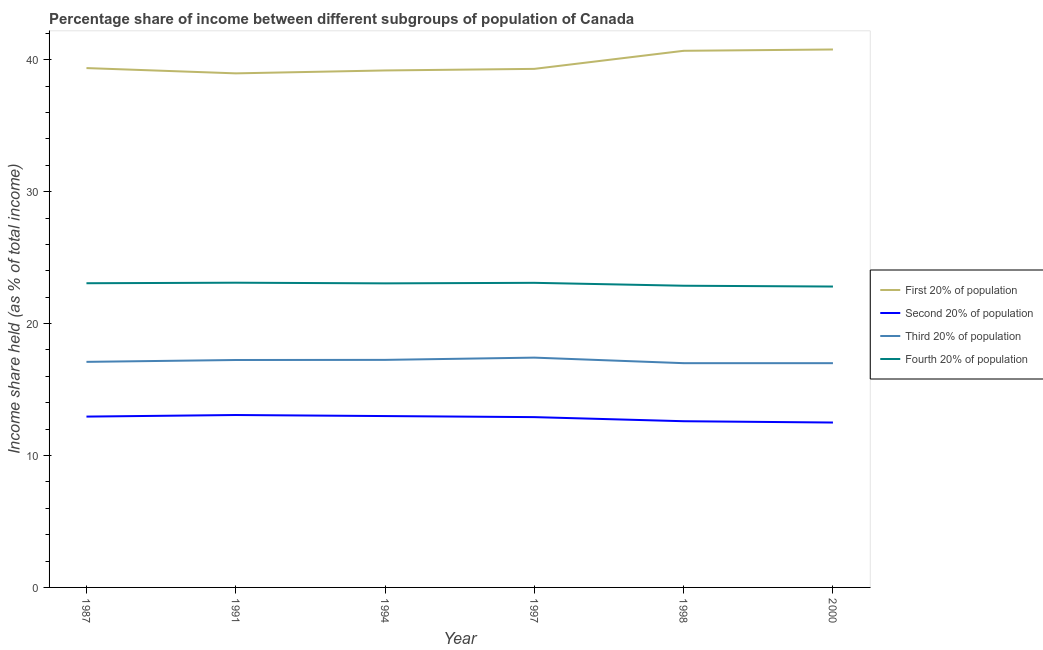Is the number of lines equal to the number of legend labels?
Ensure brevity in your answer.  Yes. What is the share of the income held by second 20% of the population in 1994?
Offer a terse response. 12.99. Across all years, what is the maximum share of the income held by second 20% of the population?
Ensure brevity in your answer.  13.07. Across all years, what is the minimum share of the income held by first 20% of the population?
Your answer should be very brief. 38.97. What is the total share of the income held by first 20% of the population in the graph?
Ensure brevity in your answer.  238.3. What is the difference between the share of the income held by first 20% of the population in 1997 and that in 1998?
Make the answer very short. -1.37. What is the difference between the share of the income held by third 20% of the population in 1994 and the share of the income held by first 20% of the population in 1987?
Your response must be concise. -22.12. What is the average share of the income held by fourth 20% of the population per year?
Offer a terse response. 23. In the year 1997, what is the difference between the share of the income held by second 20% of the population and share of the income held by third 20% of the population?
Offer a very short reply. -4.51. In how many years, is the share of the income held by second 20% of the population greater than 20 %?
Your answer should be very brief. 0. What is the ratio of the share of the income held by fourth 20% of the population in 1987 to that in 1997?
Keep it short and to the point. 1. Is the difference between the share of the income held by first 20% of the population in 1994 and 1998 greater than the difference between the share of the income held by second 20% of the population in 1994 and 1998?
Give a very brief answer. No. What is the difference between the highest and the second highest share of the income held by first 20% of the population?
Make the answer very short. 0.1. What is the difference between the highest and the lowest share of the income held by third 20% of the population?
Your answer should be very brief. 0.42. In how many years, is the share of the income held by third 20% of the population greater than the average share of the income held by third 20% of the population taken over all years?
Provide a short and direct response. 3. Is it the case that in every year, the sum of the share of the income held by first 20% of the population and share of the income held by second 20% of the population is greater than the share of the income held by third 20% of the population?
Make the answer very short. Yes. How many lines are there?
Your answer should be compact. 4. Are the values on the major ticks of Y-axis written in scientific E-notation?
Make the answer very short. No. Does the graph contain any zero values?
Ensure brevity in your answer.  No. How many legend labels are there?
Ensure brevity in your answer.  4. How are the legend labels stacked?
Offer a very short reply. Vertical. What is the title of the graph?
Offer a terse response. Percentage share of income between different subgroups of population of Canada. Does "Offering training" appear as one of the legend labels in the graph?
Your answer should be compact. No. What is the label or title of the X-axis?
Your response must be concise. Year. What is the label or title of the Y-axis?
Your answer should be very brief. Income share held (as % of total income). What is the Income share held (as % of total income) in First 20% of population in 1987?
Offer a terse response. 39.37. What is the Income share held (as % of total income) in Second 20% of population in 1987?
Keep it short and to the point. 12.95. What is the Income share held (as % of total income) in Fourth 20% of population in 1987?
Offer a terse response. 23.06. What is the Income share held (as % of total income) in First 20% of population in 1991?
Ensure brevity in your answer.  38.97. What is the Income share held (as % of total income) in Second 20% of population in 1991?
Make the answer very short. 13.07. What is the Income share held (as % of total income) of Third 20% of population in 1991?
Your answer should be compact. 17.24. What is the Income share held (as % of total income) in Fourth 20% of population in 1991?
Your response must be concise. 23.1. What is the Income share held (as % of total income) of First 20% of population in 1994?
Ensure brevity in your answer.  39.19. What is the Income share held (as % of total income) in Second 20% of population in 1994?
Keep it short and to the point. 12.99. What is the Income share held (as % of total income) of Third 20% of population in 1994?
Provide a short and direct response. 17.25. What is the Income share held (as % of total income) in Fourth 20% of population in 1994?
Keep it short and to the point. 23.05. What is the Income share held (as % of total income) of First 20% of population in 1997?
Provide a short and direct response. 39.31. What is the Income share held (as % of total income) of Second 20% of population in 1997?
Ensure brevity in your answer.  12.91. What is the Income share held (as % of total income) of Third 20% of population in 1997?
Offer a terse response. 17.42. What is the Income share held (as % of total income) in Fourth 20% of population in 1997?
Provide a short and direct response. 23.09. What is the Income share held (as % of total income) in First 20% of population in 1998?
Provide a succinct answer. 40.68. What is the Income share held (as % of total income) of Third 20% of population in 1998?
Give a very brief answer. 17. What is the Income share held (as % of total income) of Fourth 20% of population in 1998?
Offer a very short reply. 22.87. What is the Income share held (as % of total income) of First 20% of population in 2000?
Keep it short and to the point. 40.78. What is the Income share held (as % of total income) in Third 20% of population in 2000?
Your answer should be compact. 17. What is the Income share held (as % of total income) of Fourth 20% of population in 2000?
Ensure brevity in your answer.  22.81. Across all years, what is the maximum Income share held (as % of total income) of First 20% of population?
Give a very brief answer. 40.78. Across all years, what is the maximum Income share held (as % of total income) of Second 20% of population?
Keep it short and to the point. 13.07. Across all years, what is the maximum Income share held (as % of total income) of Third 20% of population?
Offer a terse response. 17.42. Across all years, what is the maximum Income share held (as % of total income) in Fourth 20% of population?
Make the answer very short. 23.1. Across all years, what is the minimum Income share held (as % of total income) in First 20% of population?
Provide a succinct answer. 38.97. Across all years, what is the minimum Income share held (as % of total income) in Third 20% of population?
Your response must be concise. 17. Across all years, what is the minimum Income share held (as % of total income) of Fourth 20% of population?
Your response must be concise. 22.81. What is the total Income share held (as % of total income) in First 20% of population in the graph?
Ensure brevity in your answer.  238.3. What is the total Income share held (as % of total income) in Second 20% of population in the graph?
Ensure brevity in your answer.  77.02. What is the total Income share held (as % of total income) of Third 20% of population in the graph?
Your answer should be compact. 103.01. What is the total Income share held (as % of total income) of Fourth 20% of population in the graph?
Provide a succinct answer. 137.98. What is the difference between the Income share held (as % of total income) in First 20% of population in 1987 and that in 1991?
Provide a short and direct response. 0.4. What is the difference between the Income share held (as % of total income) in Second 20% of population in 1987 and that in 1991?
Your response must be concise. -0.12. What is the difference between the Income share held (as % of total income) of Third 20% of population in 1987 and that in 1991?
Offer a terse response. -0.14. What is the difference between the Income share held (as % of total income) in Fourth 20% of population in 1987 and that in 1991?
Offer a terse response. -0.04. What is the difference between the Income share held (as % of total income) of First 20% of population in 1987 and that in 1994?
Keep it short and to the point. 0.18. What is the difference between the Income share held (as % of total income) in Second 20% of population in 1987 and that in 1994?
Keep it short and to the point. -0.04. What is the difference between the Income share held (as % of total income) in First 20% of population in 1987 and that in 1997?
Keep it short and to the point. 0.06. What is the difference between the Income share held (as % of total income) in Third 20% of population in 1987 and that in 1997?
Offer a very short reply. -0.32. What is the difference between the Income share held (as % of total income) in Fourth 20% of population in 1987 and that in 1997?
Provide a short and direct response. -0.03. What is the difference between the Income share held (as % of total income) in First 20% of population in 1987 and that in 1998?
Make the answer very short. -1.31. What is the difference between the Income share held (as % of total income) in Fourth 20% of population in 1987 and that in 1998?
Give a very brief answer. 0.19. What is the difference between the Income share held (as % of total income) of First 20% of population in 1987 and that in 2000?
Your answer should be compact. -1.41. What is the difference between the Income share held (as % of total income) in Second 20% of population in 1987 and that in 2000?
Keep it short and to the point. 0.45. What is the difference between the Income share held (as % of total income) of Third 20% of population in 1987 and that in 2000?
Provide a short and direct response. 0.1. What is the difference between the Income share held (as % of total income) of First 20% of population in 1991 and that in 1994?
Give a very brief answer. -0.22. What is the difference between the Income share held (as % of total income) in Second 20% of population in 1991 and that in 1994?
Keep it short and to the point. 0.08. What is the difference between the Income share held (as % of total income) in Third 20% of population in 1991 and that in 1994?
Your response must be concise. -0.01. What is the difference between the Income share held (as % of total income) in First 20% of population in 1991 and that in 1997?
Offer a very short reply. -0.34. What is the difference between the Income share held (as % of total income) in Second 20% of population in 1991 and that in 1997?
Your answer should be compact. 0.16. What is the difference between the Income share held (as % of total income) in Third 20% of population in 1991 and that in 1997?
Ensure brevity in your answer.  -0.18. What is the difference between the Income share held (as % of total income) of First 20% of population in 1991 and that in 1998?
Keep it short and to the point. -1.71. What is the difference between the Income share held (as % of total income) in Second 20% of population in 1991 and that in 1998?
Give a very brief answer. 0.47. What is the difference between the Income share held (as % of total income) of Third 20% of population in 1991 and that in 1998?
Your response must be concise. 0.24. What is the difference between the Income share held (as % of total income) in Fourth 20% of population in 1991 and that in 1998?
Offer a very short reply. 0.23. What is the difference between the Income share held (as % of total income) of First 20% of population in 1991 and that in 2000?
Your answer should be very brief. -1.81. What is the difference between the Income share held (as % of total income) of Second 20% of population in 1991 and that in 2000?
Make the answer very short. 0.57. What is the difference between the Income share held (as % of total income) in Third 20% of population in 1991 and that in 2000?
Your answer should be compact. 0.24. What is the difference between the Income share held (as % of total income) of Fourth 20% of population in 1991 and that in 2000?
Keep it short and to the point. 0.29. What is the difference between the Income share held (as % of total income) of First 20% of population in 1994 and that in 1997?
Your answer should be compact. -0.12. What is the difference between the Income share held (as % of total income) of Third 20% of population in 1994 and that in 1997?
Give a very brief answer. -0.17. What is the difference between the Income share held (as % of total income) of Fourth 20% of population in 1994 and that in 1997?
Provide a succinct answer. -0.04. What is the difference between the Income share held (as % of total income) of First 20% of population in 1994 and that in 1998?
Provide a short and direct response. -1.49. What is the difference between the Income share held (as % of total income) of Second 20% of population in 1994 and that in 1998?
Provide a succinct answer. 0.39. What is the difference between the Income share held (as % of total income) of Third 20% of population in 1994 and that in 1998?
Provide a succinct answer. 0.25. What is the difference between the Income share held (as % of total income) in Fourth 20% of population in 1994 and that in 1998?
Give a very brief answer. 0.18. What is the difference between the Income share held (as % of total income) of First 20% of population in 1994 and that in 2000?
Provide a succinct answer. -1.59. What is the difference between the Income share held (as % of total income) in Second 20% of population in 1994 and that in 2000?
Make the answer very short. 0.49. What is the difference between the Income share held (as % of total income) of Fourth 20% of population in 1994 and that in 2000?
Offer a terse response. 0.24. What is the difference between the Income share held (as % of total income) in First 20% of population in 1997 and that in 1998?
Keep it short and to the point. -1.37. What is the difference between the Income share held (as % of total income) in Second 20% of population in 1997 and that in 1998?
Give a very brief answer. 0.31. What is the difference between the Income share held (as % of total income) in Third 20% of population in 1997 and that in 1998?
Keep it short and to the point. 0.42. What is the difference between the Income share held (as % of total income) in Fourth 20% of population in 1997 and that in 1998?
Make the answer very short. 0.22. What is the difference between the Income share held (as % of total income) in First 20% of population in 1997 and that in 2000?
Make the answer very short. -1.47. What is the difference between the Income share held (as % of total income) in Second 20% of population in 1997 and that in 2000?
Keep it short and to the point. 0.41. What is the difference between the Income share held (as % of total income) of Third 20% of population in 1997 and that in 2000?
Provide a succinct answer. 0.42. What is the difference between the Income share held (as % of total income) of Fourth 20% of population in 1997 and that in 2000?
Ensure brevity in your answer.  0.28. What is the difference between the Income share held (as % of total income) of First 20% of population in 1998 and that in 2000?
Your response must be concise. -0.1. What is the difference between the Income share held (as % of total income) of First 20% of population in 1987 and the Income share held (as % of total income) of Second 20% of population in 1991?
Your answer should be compact. 26.3. What is the difference between the Income share held (as % of total income) of First 20% of population in 1987 and the Income share held (as % of total income) of Third 20% of population in 1991?
Your answer should be compact. 22.13. What is the difference between the Income share held (as % of total income) in First 20% of population in 1987 and the Income share held (as % of total income) in Fourth 20% of population in 1991?
Your answer should be very brief. 16.27. What is the difference between the Income share held (as % of total income) in Second 20% of population in 1987 and the Income share held (as % of total income) in Third 20% of population in 1991?
Provide a succinct answer. -4.29. What is the difference between the Income share held (as % of total income) of Second 20% of population in 1987 and the Income share held (as % of total income) of Fourth 20% of population in 1991?
Offer a very short reply. -10.15. What is the difference between the Income share held (as % of total income) of First 20% of population in 1987 and the Income share held (as % of total income) of Second 20% of population in 1994?
Your answer should be very brief. 26.38. What is the difference between the Income share held (as % of total income) in First 20% of population in 1987 and the Income share held (as % of total income) in Third 20% of population in 1994?
Provide a succinct answer. 22.12. What is the difference between the Income share held (as % of total income) in First 20% of population in 1987 and the Income share held (as % of total income) in Fourth 20% of population in 1994?
Ensure brevity in your answer.  16.32. What is the difference between the Income share held (as % of total income) in Second 20% of population in 1987 and the Income share held (as % of total income) in Third 20% of population in 1994?
Make the answer very short. -4.3. What is the difference between the Income share held (as % of total income) of Third 20% of population in 1987 and the Income share held (as % of total income) of Fourth 20% of population in 1994?
Offer a very short reply. -5.95. What is the difference between the Income share held (as % of total income) in First 20% of population in 1987 and the Income share held (as % of total income) in Second 20% of population in 1997?
Keep it short and to the point. 26.46. What is the difference between the Income share held (as % of total income) of First 20% of population in 1987 and the Income share held (as % of total income) of Third 20% of population in 1997?
Your answer should be compact. 21.95. What is the difference between the Income share held (as % of total income) in First 20% of population in 1987 and the Income share held (as % of total income) in Fourth 20% of population in 1997?
Your response must be concise. 16.28. What is the difference between the Income share held (as % of total income) in Second 20% of population in 1987 and the Income share held (as % of total income) in Third 20% of population in 1997?
Your answer should be very brief. -4.47. What is the difference between the Income share held (as % of total income) of Second 20% of population in 1987 and the Income share held (as % of total income) of Fourth 20% of population in 1997?
Make the answer very short. -10.14. What is the difference between the Income share held (as % of total income) in Third 20% of population in 1987 and the Income share held (as % of total income) in Fourth 20% of population in 1997?
Ensure brevity in your answer.  -5.99. What is the difference between the Income share held (as % of total income) of First 20% of population in 1987 and the Income share held (as % of total income) of Second 20% of population in 1998?
Provide a short and direct response. 26.77. What is the difference between the Income share held (as % of total income) of First 20% of population in 1987 and the Income share held (as % of total income) of Third 20% of population in 1998?
Make the answer very short. 22.37. What is the difference between the Income share held (as % of total income) of First 20% of population in 1987 and the Income share held (as % of total income) of Fourth 20% of population in 1998?
Your answer should be compact. 16.5. What is the difference between the Income share held (as % of total income) of Second 20% of population in 1987 and the Income share held (as % of total income) of Third 20% of population in 1998?
Your response must be concise. -4.05. What is the difference between the Income share held (as % of total income) in Second 20% of population in 1987 and the Income share held (as % of total income) in Fourth 20% of population in 1998?
Give a very brief answer. -9.92. What is the difference between the Income share held (as % of total income) of Third 20% of population in 1987 and the Income share held (as % of total income) of Fourth 20% of population in 1998?
Provide a succinct answer. -5.77. What is the difference between the Income share held (as % of total income) in First 20% of population in 1987 and the Income share held (as % of total income) in Second 20% of population in 2000?
Your answer should be compact. 26.87. What is the difference between the Income share held (as % of total income) in First 20% of population in 1987 and the Income share held (as % of total income) in Third 20% of population in 2000?
Give a very brief answer. 22.37. What is the difference between the Income share held (as % of total income) in First 20% of population in 1987 and the Income share held (as % of total income) in Fourth 20% of population in 2000?
Provide a short and direct response. 16.56. What is the difference between the Income share held (as % of total income) of Second 20% of population in 1987 and the Income share held (as % of total income) of Third 20% of population in 2000?
Make the answer very short. -4.05. What is the difference between the Income share held (as % of total income) in Second 20% of population in 1987 and the Income share held (as % of total income) in Fourth 20% of population in 2000?
Your answer should be compact. -9.86. What is the difference between the Income share held (as % of total income) of Third 20% of population in 1987 and the Income share held (as % of total income) of Fourth 20% of population in 2000?
Provide a succinct answer. -5.71. What is the difference between the Income share held (as % of total income) of First 20% of population in 1991 and the Income share held (as % of total income) of Second 20% of population in 1994?
Give a very brief answer. 25.98. What is the difference between the Income share held (as % of total income) of First 20% of population in 1991 and the Income share held (as % of total income) of Third 20% of population in 1994?
Offer a terse response. 21.72. What is the difference between the Income share held (as % of total income) in First 20% of population in 1991 and the Income share held (as % of total income) in Fourth 20% of population in 1994?
Provide a succinct answer. 15.92. What is the difference between the Income share held (as % of total income) of Second 20% of population in 1991 and the Income share held (as % of total income) of Third 20% of population in 1994?
Keep it short and to the point. -4.18. What is the difference between the Income share held (as % of total income) of Second 20% of population in 1991 and the Income share held (as % of total income) of Fourth 20% of population in 1994?
Give a very brief answer. -9.98. What is the difference between the Income share held (as % of total income) of Third 20% of population in 1991 and the Income share held (as % of total income) of Fourth 20% of population in 1994?
Offer a very short reply. -5.81. What is the difference between the Income share held (as % of total income) of First 20% of population in 1991 and the Income share held (as % of total income) of Second 20% of population in 1997?
Your response must be concise. 26.06. What is the difference between the Income share held (as % of total income) in First 20% of population in 1991 and the Income share held (as % of total income) in Third 20% of population in 1997?
Give a very brief answer. 21.55. What is the difference between the Income share held (as % of total income) of First 20% of population in 1991 and the Income share held (as % of total income) of Fourth 20% of population in 1997?
Make the answer very short. 15.88. What is the difference between the Income share held (as % of total income) of Second 20% of population in 1991 and the Income share held (as % of total income) of Third 20% of population in 1997?
Your answer should be very brief. -4.35. What is the difference between the Income share held (as % of total income) of Second 20% of population in 1991 and the Income share held (as % of total income) of Fourth 20% of population in 1997?
Provide a succinct answer. -10.02. What is the difference between the Income share held (as % of total income) of Third 20% of population in 1991 and the Income share held (as % of total income) of Fourth 20% of population in 1997?
Provide a short and direct response. -5.85. What is the difference between the Income share held (as % of total income) of First 20% of population in 1991 and the Income share held (as % of total income) of Second 20% of population in 1998?
Your answer should be compact. 26.37. What is the difference between the Income share held (as % of total income) in First 20% of population in 1991 and the Income share held (as % of total income) in Third 20% of population in 1998?
Your answer should be compact. 21.97. What is the difference between the Income share held (as % of total income) of First 20% of population in 1991 and the Income share held (as % of total income) of Fourth 20% of population in 1998?
Offer a very short reply. 16.1. What is the difference between the Income share held (as % of total income) of Second 20% of population in 1991 and the Income share held (as % of total income) of Third 20% of population in 1998?
Your answer should be very brief. -3.93. What is the difference between the Income share held (as % of total income) of Second 20% of population in 1991 and the Income share held (as % of total income) of Fourth 20% of population in 1998?
Offer a terse response. -9.8. What is the difference between the Income share held (as % of total income) of Third 20% of population in 1991 and the Income share held (as % of total income) of Fourth 20% of population in 1998?
Your answer should be very brief. -5.63. What is the difference between the Income share held (as % of total income) of First 20% of population in 1991 and the Income share held (as % of total income) of Second 20% of population in 2000?
Your answer should be compact. 26.47. What is the difference between the Income share held (as % of total income) of First 20% of population in 1991 and the Income share held (as % of total income) of Third 20% of population in 2000?
Ensure brevity in your answer.  21.97. What is the difference between the Income share held (as % of total income) of First 20% of population in 1991 and the Income share held (as % of total income) of Fourth 20% of population in 2000?
Your answer should be compact. 16.16. What is the difference between the Income share held (as % of total income) of Second 20% of population in 1991 and the Income share held (as % of total income) of Third 20% of population in 2000?
Provide a succinct answer. -3.93. What is the difference between the Income share held (as % of total income) of Second 20% of population in 1991 and the Income share held (as % of total income) of Fourth 20% of population in 2000?
Provide a succinct answer. -9.74. What is the difference between the Income share held (as % of total income) in Third 20% of population in 1991 and the Income share held (as % of total income) in Fourth 20% of population in 2000?
Provide a succinct answer. -5.57. What is the difference between the Income share held (as % of total income) of First 20% of population in 1994 and the Income share held (as % of total income) of Second 20% of population in 1997?
Your answer should be compact. 26.28. What is the difference between the Income share held (as % of total income) in First 20% of population in 1994 and the Income share held (as % of total income) in Third 20% of population in 1997?
Your answer should be very brief. 21.77. What is the difference between the Income share held (as % of total income) in First 20% of population in 1994 and the Income share held (as % of total income) in Fourth 20% of population in 1997?
Ensure brevity in your answer.  16.1. What is the difference between the Income share held (as % of total income) in Second 20% of population in 1994 and the Income share held (as % of total income) in Third 20% of population in 1997?
Offer a very short reply. -4.43. What is the difference between the Income share held (as % of total income) of Second 20% of population in 1994 and the Income share held (as % of total income) of Fourth 20% of population in 1997?
Your answer should be compact. -10.1. What is the difference between the Income share held (as % of total income) in Third 20% of population in 1994 and the Income share held (as % of total income) in Fourth 20% of population in 1997?
Offer a very short reply. -5.84. What is the difference between the Income share held (as % of total income) of First 20% of population in 1994 and the Income share held (as % of total income) of Second 20% of population in 1998?
Offer a very short reply. 26.59. What is the difference between the Income share held (as % of total income) in First 20% of population in 1994 and the Income share held (as % of total income) in Third 20% of population in 1998?
Keep it short and to the point. 22.19. What is the difference between the Income share held (as % of total income) in First 20% of population in 1994 and the Income share held (as % of total income) in Fourth 20% of population in 1998?
Make the answer very short. 16.32. What is the difference between the Income share held (as % of total income) of Second 20% of population in 1994 and the Income share held (as % of total income) of Third 20% of population in 1998?
Offer a very short reply. -4.01. What is the difference between the Income share held (as % of total income) in Second 20% of population in 1994 and the Income share held (as % of total income) in Fourth 20% of population in 1998?
Give a very brief answer. -9.88. What is the difference between the Income share held (as % of total income) in Third 20% of population in 1994 and the Income share held (as % of total income) in Fourth 20% of population in 1998?
Provide a succinct answer. -5.62. What is the difference between the Income share held (as % of total income) of First 20% of population in 1994 and the Income share held (as % of total income) of Second 20% of population in 2000?
Your response must be concise. 26.69. What is the difference between the Income share held (as % of total income) in First 20% of population in 1994 and the Income share held (as % of total income) in Third 20% of population in 2000?
Offer a very short reply. 22.19. What is the difference between the Income share held (as % of total income) in First 20% of population in 1994 and the Income share held (as % of total income) in Fourth 20% of population in 2000?
Offer a terse response. 16.38. What is the difference between the Income share held (as % of total income) of Second 20% of population in 1994 and the Income share held (as % of total income) of Third 20% of population in 2000?
Offer a terse response. -4.01. What is the difference between the Income share held (as % of total income) of Second 20% of population in 1994 and the Income share held (as % of total income) of Fourth 20% of population in 2000?
Provide a succinct answer. -9.82. What is the difference between the Income share held (as % of total income) in Third 20% of population in 1994 and the Income share held (as % of total income) in Fourth 20% of population in 2000?
Provide a succinct answer. -5.56. What is the difference between the Income share held (as % of total income) of First 20% of population in 1997 and the Income share held (as % of total income) of Second 20% of population in 1998?
Provide a succinct answer. 26.71. What is the difference between the Income share held (as % of total income) in First 20% of population in 1997 and the Income share held (as % of total income) in Third 20% of population in 1998?
Keep it short and to the point. 22.31. What is the difference between the Income share held (as % of total income) in First 20% of population in 1997 and the Income share held (as % of total income) in Fourth 20% of population in 1998?
Your response must be concise. 16.44. What is the difference between the Income share held (as % of total income) of Second 20% of population in 1997 and the Income share held (as % of total income) of Third 20% of population in 1998?
Provide a succinct answer. -4.09. What is the difference between the Income share held (as % of total income) of Second 20% of population in 1997 and the Income share held (as % of total income) of Fourth 20% of population in 1998?
Your answer should be very brief. -9.96. What is the difference between the Income share held (as % of total income) in Third 20% of population in 1997 and the Income share held (as % of total income) in Fourth 20% of population in 1998?
Offer a very short reply. -5.45. What is the difference between the Income share held (as % of total income) in First 20% of population in 1997 and the Income share held (as % of total income) in Second 20% of population in 2000?
Make the answer very short. 26.81. What is the difference between the Income share held (as % of total income) in First 20% of population in 1997 and the Income share held (as % of total income) in Third 20% of population in 2000?
Make the answer very short. 22.31. What is the difference between the Income share held (as % of total income) in Second 20% of population in 1997 and the Income share held (as % of total income) in Third 20% of population in 2000?
Your response must be concise. -4.09. What is the difference between the Income share held (as % of total income) in Third 20% of population in 1997 and the Income share held (as % of total income) in Fourth 20% of population in 2000?
Provide a short and direct response. -5.39. What is the difference between the Income share held (as % of total income) of First 20% of population in 1998 and the Income share held (as % of total income) of Second 20% of population in 2000?
Your response must be concise. 28.18. What is the difference between the Income share held (as % of total income) of First 20% of population in 1998 and the Income share held (as % of total income) of Third 20% of population in 2000?
Provide a succinct answer. 23.68. What is the difference between the Income share held (as % of total income) of First 20% of population in 1998 and the Income share held (as % of total income) of Fourth 20% of population in 2000?
Keep it short and to the point. 17.87. What is the difference between the Income share held (as % of total income) of Second 20% of population in 1998 and the Income share held (as % of total income) of Third 20% of population in 2000?
Offer a terse response. -4.4. What is the difference between the Income share held (as % of total income) in Second 20% of population in 1998 and the Income share held (as % of total income) in Fourth 20% of population in 2000?
Your answer should be compact. -10.21. What is the difference between the Income share held (as % of total income) in Third 20% of population in 1998 and the Income share held (as % of total income) in Fourth 20% of population in 2000?
Keep it short and to the point. -5.81. What is the average Income share held (as % of total income) of First 20% of population per year?
Make the answer very short. 39.72. What is the average Income share held (as % of total income) in Second 20% of population per year?
Keep it short and to the point. 12.84. What is the average Income share held (as % of total income) of Third 20% of population per year?
Provide a short and direct response. 17.17. What is the average Income share held (as % of total income) of Fourth 20% of population per year?
Provide a succinct answer. 23. In the year 1987, what is the difference between the Income share held (as % of total income) of First 20% of population and Income share held (as % of total income) of Second 20% of population?
Your answer should be compact. 26.42. In the year 1987, what is the difference between the Income share held (as % of total income) in First 20% of population and Income share held (as % of total income) in Third 20% of population?
Give a very brief answer. 22.27. In the year 1987, what is the difference between the Income share held (as % of total income) of First 20% of population and Income share held (as % of total income) of Fourth 20% of population?
Your answer should be compact. 16.31. In the year 1987, what is the difference between the Income share held (as % of total income) of Second 20% of population and Income share held (as % of total income) of Third 20% of population?
Your answer should be compact. -4.15. In the year 1987, what is the difference between the Income share held (as % of total income) in Second 20% of population and Income share held (as % of total income) in Fourth 20% of population?
Make the answer very short. -10.11. In the year 1987, what is the difference between the Income share held (as % of total income) in Third 20% of population and Income share held (as % of total income) in Fourth 20% of population?
Your answer should be very brief. -5.96. In the year 1991, what is the difference between the Income share held (as % of total income) in First 20% of population and Income share held (as % of total income) in Second 20% of population?
Offer a very short reply. 25.9. In the year 1991, what is the difference between the Income share held (as % of total income) in First 20% of population and Income share held (as % of total income) in Third 20% of population?
Give a very brief answer. 21.73. In the year 1991, what is the difference between the Income share held (as % of total income) in First 20% of population and Income share held (as % of total income) in Fourth 20% of population?
Provide a short and direct response. 15.87. In the year 1991, what is the difference between the Income share held (as % of total income) of Second 20% of population and Income share held (as % of total income) of Third 20% of population?
Your answer should be compact. -4.17. In the year 1991, what is the difference between the Income share held (as % of total income) of Second 20% of population and Income share held (as % of total income) of Fourth 20% of population?
Ensure brevity in your answer.  -10.03. In the year 1991, what is the difference between the Income share held (as % of total income) of Third 20% of population and Income share held (as % of total income) of Fourth 20% of population?
Your response must be concise. -5.86. In the year 1994, what is the difference between the Income share held (as % of total income) in First 20% of population and Income share held (as % of total income) in Second 20% of population?
Provide a short and direct response. 26.2. In the year 1994, what is the difference between the Income share held (as % of total income) of First 20% of population and Income share held (as % of total income) of Third 20% of population?
Provide a succinct answer. 21.94. In the year 1994, what is the difference between the Income share held (as % of total income) of First 20% of population and Income share held (as % of total income) of Fourth 20% of population?
Your answer should be very brief. 16.14. In the year 1994, what is the difference between the Income share held (as % of total income) in Second 20% of population and Income share held (as % of total income) in Third 20% of population?
Give a very brief answer. -4.26. In the year 1994, what is the difference between the Income share held (as % of total income) in Second 20% of population and Income share held (as % of total income) in Fourth 20% of population?
Keep it short and to the point. -10.06. In the year 1994, what is the difference between the Income share held (as % of total income) in Third 20% of population and Income share held (as % of total income) in Fourth 20% of population?
Ensure brevity in your answer.  -5.8. In the year 1997, what is the difference between the Income share held (as % of total income) of First 20% of population and Income share held (as % of total income) of Second 20% of population?
Your answer should be very brief. 26.4. In the year 1997, what is the difference between the Income share held (as % of total income) in First 20% of population and Income share held (as % of total income) in Third 20% of population?
Provide a succinct answer. 21.89. In the year 1997, what is the difference between the Income share held (as % of total income) in First 20% of population and Income share held (as % of total income) in Fourth 20% of population?
Your answer should be very brief. 16.22. In the year 1997, what is the difference between the Income share held (as % of total income) in Second 20% of population and Income share held (as % of total income) in Third 20% of population?
Your answer should be very brief. -4.51. In the year 1997, what is the difference between the Income share held (as % of total income) of Second 20% of population and Income share held (as % of total income) of Fourth 20% of population?
Keep it short and to the point. -10.18. In the year 1997, what is the difference between the Income share held (as % of total income) in Third 20% of population and Income share held (as % of total income) in Fourth 20% of population?
Ensure brevity in your answer.  -5.67. In the year 1998, what is the difference between the Income share held (as % of total income) in First 20% of population and Income share held (as % of total income) in Second 20% of population?
Offer a terse response. 28.08. In the year 1998, what is the difference between the Income share held (as % of total income) of First 20% of population and Income share held (as % of total income) of Third 20% of population?
Provide a short and direct response. 23.68. In the year 1998, what is the difference between the Income share held (as % of total income) of First 20% of population and Income share held (as % of total income) of Fourth 20% of population?
Give a very brief answer. 17.81. In the year 1998, what is the difference between the Income share held (as % of total income) of Second 20% of population and Income share held (as % of total income) of Fourth 20% of population?
Make the answer very short. -10.27. In the year 1998, what is the difference between the Income share held (as % of total income) of Third 20% of population and Income share held (as % of total income) of Fourth 20% of population?
Give a very brief answer. -5.87. In the year 2000, what is the difference between the Income share held (as % of total income) in First 20% of population and Income share held (as % of total income) in Second 20% of population?
Provide a short and direct response. 28.28. In the year 2000, what is the difference between the Income share held (as % of total income) in First 20% of population and Income share held (as % of total income) in Third 20% of population?
Give a very brief answer. 23.78. In the year 2000, what is the difference between the Income share held (as % of total income) in First 20% of population and Income share held (as % of total income) in Fourth 20% of population?
Make the answer very short. 17.97. In the year 2000, what is the difference between the Income share held (as % of total income) of Second 20% of population and Income share held (as % of total income) of Third 20% of population?
Give a very brief answer. -4.5. In the year 2000, what is the difference between the Income share held (as % of total income) in Second 20% of population and Income share held (as % of total income) in Fourth 20% of population?
Ensure brevity in your answer.  -10.31. In the year 2000, what is the difference between the Income share held (as % of total income) of Third 20% of population and Income share held (as % of total income) of Fourth 20% of population?
Offer a very short reply. -5.81. What is the ratio of the Income share held (as % of total income) in First 20% of population in 1987 to that in 1991?
Give a very brief answer. 1.01. What is the ratio of the Income share held (as % of total income) of Second 20% of population in 1987 to that in 1991?
Provide a succinct answer. 0.99. What is the ratio of the Income share held (as % of total income) in Third 20% of population in 1987 to that in 1991?
Your response must be concise. 0.99. What is the ratio of the Income share held (as % of total income) in Third 20% of population in 1987 to that in 1994?
Your response must be concise. 0.99. What is the ratio of the Income share held (as % of total income) of Fourth 20% of population in 1987 to that in 1994?
Ensure brevity in your answer.  1. What is the ratio of the Income share held (as % of total income) of First 20% of population in 1987 to that in 1997?
Provide a succinct answer. 1. What is the ratio of the Income share held (as % of total income) in Third 20% of population in 1987 to that in 1997?
Your answer should be very brief. 0.98. What is the ratio of the Income share held (as % of total income) of Fourth 20% of population in 1987 to that in 1997?
Ensure brevity in your answer.  1. What is the ratio of the Income share held (as % of total income) in First 20% of population in 1987 to that in 1998?
Your answer should be very brief. 0.97. What is the ratio of the Income share held (as % of total income) in Second 20% of population in 1987 to that in 1998?
Your response must be concise. 1.03. What is the ratio of the Income share held (as % of total income) in Third 20% of population in 1987 to that in 1998?
Keep it short and to the point. 1.01. What is the ratio of the Income share held (as % of total income) in Fourth 20% of population in 1987 to that in 1998?
Your answer should be compact. 1.01. What is the ratio of the Income share held (as % of total income) in First 20% of population in 1987 to that in 2000?
Offer a very short reply. 0.97. What is the ratio of the Income share held (as % of total income) in Second 20% of population in 1987 to that in 2000?
Offer a very short reply. 1.04. What is the ratio of the Income share held (as % of total income) in Third 20% of population in 1987 to that in 2000?
Offer a terse response. 1.01. What is the ratio of the Income share held (as % of total income) in Fourth 20% of population in 1987 to that in 2000?
Offer a very short reply. 1.01. What is the ratio of the Income share held (as % of total income) of Fourth 20% of population in 1991 to that in 1994?
Offer a very short reply. 1. What is the ratio of the Income share held (as % of total income) in Second 20% of population in 1991 to that in 1997?
Your answer should be very brief. 1.01. What is the ratio of the Income share held (as % of total income) in Third 20% of population in 1991 to that in 1997?
Your response must be concise. 0.99. What is the ratio of the Income share held (as % of total income) in Fourth 20% of population in 1991 to that in 1997?
Make the answer very short. 1. What is the ratio of the Income share held (as % of total income) of First 20% of population in 1991 to that in 1998?
Give a very brief answer. 0.96. What is the ratio of the Income share held (as % of total income) of Second 20% of population in 1991 to that in 1998?
Offer a very short reply. 1.04. What is the ratio of the Income share held (as % of total income) of Third 20% of population in 1991 to that in 1998?
Give a very brief answer. 1.01. What is the ratio of the Income share held (as % of total income) of Fourth 20% of population in 1991 to that in 1998?
Provide a succinct answer. 1.01. What is the ratio of the Income share held (as % of total income) in First 20% of population in 1991 to that in 2000?
Ensure brevity in your answer.  0.96. What is the ratio of the Income share held (as % of total income) in Second 20% of population in 1991 to that in 2000?
Make the answer very short. 1.05. What is the ratio of the Income share held (as % of total income) of Third 20% of population in 1991 to that in 2000?
Make the answer very short. 1.01. What is the ratio of the Income share held (as % of total income) of Fourth 20% of population in 1991 to that in 2000?
Provide a succinct answer. 1.01. What is the ratio of the Income share held (as % of total income) of Third 20% of population in 1994 to that in 1997?
Your answer should be compact. 0.99. What is the ratio of the Income share held (as % of total income) in First 20% of population in 1994 to that in 1998?
Provide a succinct answer. 0.96. What is the ratio of the Income share held (as % of total income) of Second 20% of population in 1994 to that in 1998?
Your answer should be very brief. 1.03. What is the ratio of the Income share held (as % of total income) of Third 20% of population in 1994 to that in 1998?
Offer a very short reply. 1.01. What is the ratio of the Income share held (as % of total income) of Fourth 20% of population in 1994 to that in 1998?
Provide a succinct answer. 1.01. What is the ratio of the Income share held (as % of total income) of First 20% of population in 1994 to that in 2000?
Your answer should be compact. 0.96. What is the ratio of the Income share held (as % of total income) in Second 20% of population in 1994 to that in 2000?
Your answer should be compact. 1.04. What is the ratio of the Income share held (as % of total income) in Third 20% of population in 1994 to that in 2000?
Keep it short and to the point. 1.01. What is the ratio of the Income share held (as % of total income) of Fourth 20% of population in 1994 to that in 2000?
Your response must be concise. 1.01. What is the ratio of the Income share held (as % of total income) of First 20% of population in 1997 to that in 1998?
Your response must be concise. 0.97. What is the ratio of the Income share held (as % of total income) in Second 20% of population in 1997 to that in 1998?
Make the answer very short. 1.02. What is the ratio of the Income share held (as % of total income) of Third 20% of population in 1997 to that in 1998?
Give a very brief answer. 1.02. What is the ratio of the Income share held (as % of total income) of Fourth 20% of population in 1997 to that in 1998?
Your answer should be compact. 1.01. What is the ratio of the Income share held (as % of total income) of First 20% of population in 1997 to that in 2000?
Your response must be concise. 0.96. What is the ratio of the Income share held (as % of total income) in Second 20% of population in 1997 to that in 2000?
Keep it short and to the point. 1.03. What is the ratio of the Income share held (as % of total income) of Third 20% of population in 1997 to that in 2000?
Your answer should be very brief. 1.02. What is the ratio of the Income share held (as % of total income) of Fourth 20% of population in 1997 to that in 2000?
Give a very brief answer. 1.01. What is the ratio of the Income share held (as % of total income) in First 20% of population in 1998 to that in 2000?
Provide a succinct answer. 1. What is the ratio of the Income share held (as % of total income) of Second 20% of population in 1998 to that in 2000?
Your answer should be compact. 1.01. What is the ratio of the Income share held (as % of total income) of Fourth 20% of population in 1998 to that in 2000?
Your answer should be very brief. 1. What is the difference between the highest and the second highest Income share held (as % of total income) of Third 20% of population?
Ensure brevity in your answer.  0.17. What is the difference between the highest and the second highest Income share held (as % of total income) in Fourth 20% of population?
Ensure brevity in your answer.  0.01. What is the difference between the highest and the lowest Income share held (as % of total income) in First 20% of population?
Make the answer very short. 1.81. What is the difference between the highest and the lowest Income share held (as % of total income) in Second 20% of population?
Offer a terse response. 0.57. What is the difference between the highest and the lowest Income share held (as % of total income) of Third 20% of population?
Provide a short and direct response. 0.42. What is the difference between the highest and the lowest Income share held (as % of total income) of Fourth 20% of population?
Your answer should be very brief. 0.29. 